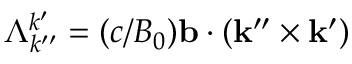Convert formula to latex. <formula><loc_0><loc_0><loc_500><loc_500>\Lambda _ { k ^ { \prime \prime } } ^ { k ^ { \prime } } = ( c / B _ { 0 } ) b \cdot ( k ^ { \prime \prime } \times k ^ { \prime } )</formula> 